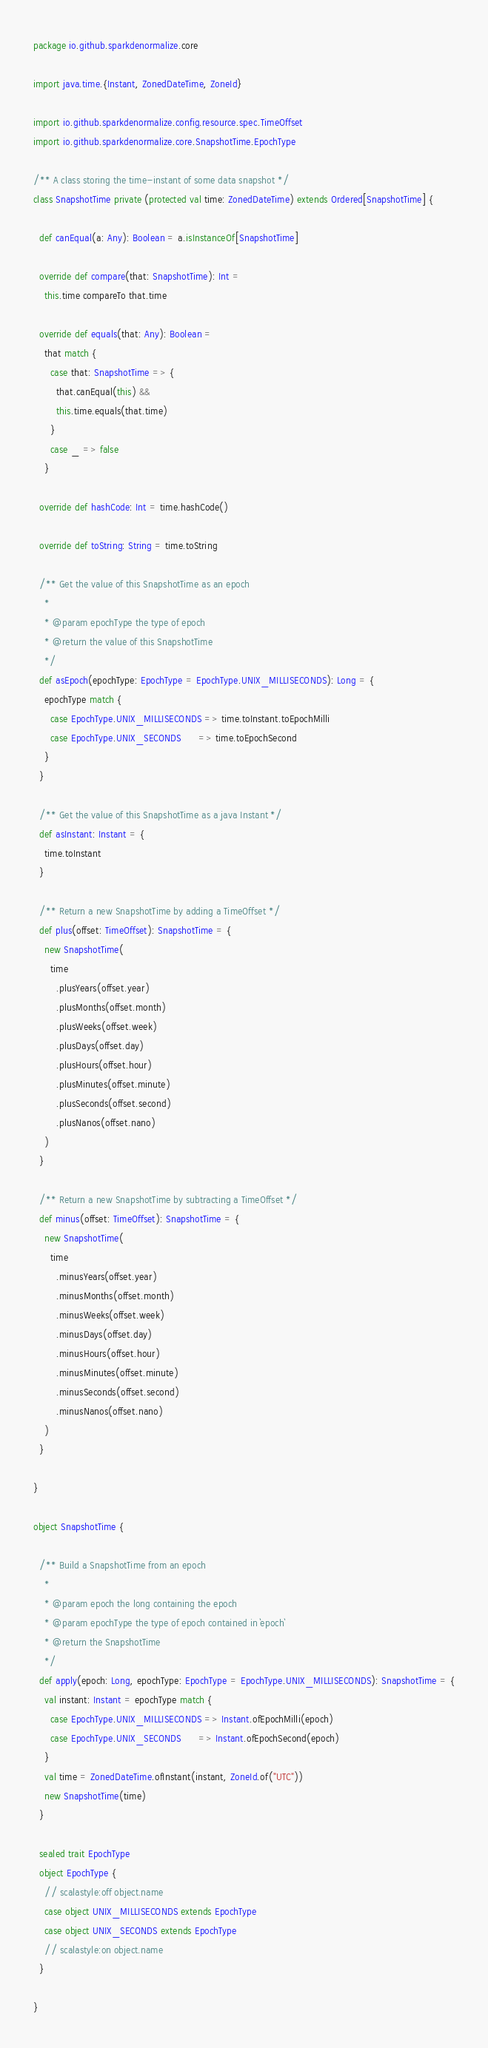Convert code to text. <code><loc_0><loc_0><loc_500><loc_500><_Scala_>package io.github.sparkdenormalize.core

import java.time.{Instant, ZonedDateTime, ZoneId}

import io.github.sparkdenormalize.config.resource.spec.TimeOffset
import io.github.sparkdenormalize.core.SnapshotTime.EpochType

/** A class storing the time-instant of some data snapshot */
class SnapshotTime private (protected val time: ZonedDateTime) extends Ordered[SnapshotTime] {

  def canEqual(a: Any): Boolean = a.isInstanceOf[SnapshotTime]

  override def compare(that: SnapshotTime): Int =
    this.time compareTo that.time

  override def equals(that: Any): Boolean =
    that match {
      case that: SnapshotTime => {
        that.canEqual(this) &&
        this.time.equals(that.time)
      }
      case _ => false
    }

  override def hashCode: Int = time.hashCode()

  override def toString: String = time.toString

  /** Get the value of this SnapshotTime as an epoch
    *
    * @param epochType the type of epoch
    * @return the value of this SnapshotTime
    */
  def asEpoch(epochType: EpochType = EpochType.UNIX_MILLISECONDS): Long = {
    epochType match {
      case EpochType.UNIX_MILLISECONDS => time.toInstant.toEpochMilli
      case EpochType.UNIX_SECONDS      => time.toEpochSecond
    }
  }

  /** Get the value of this SnapshotTime as a java Instant */
  def asInstant: Instant = {
    time.toInstant
  }

  /** Return a new SnapshotTime by adding a TimeOffset */
  def plus(offset: TimeOffset): SnapshotTime = {
    new SnapshotTime(
      time
        .plusYears(offset.year)
        .plusMonths(offset.month)
        .plusWeeks(offset.week)
        .plusDays(offset.day)
        .plusHours(offset.hour)
        .plusMinutes(offset.minute)
        .plusSeconds(offset.second)
        .plusNanos(offset.nano)
    )
  }

  /** Return a new SnapshotTime by subtracting a TimeOffset */
  def minus(offset: TimeOffset): SnapshotTime = {
    new SnapshotTime(
      time
        .minusYears(offset.year)
        .minusMonths(offset.month)
        .minusWeeks(offset.week)
        .minusDays(offset.day)
        .minusHours(offset.hour)
        .minusMinutes(offset.minute)
        .minusSeconds(offset.second)
        .minusNanos(offset.nano)
    )
  }

}

object SnapshotTime {

  /** Build a SnapshotTime from an epoch
    *
    * @param epoch the long containing the epoch
    * @param epochType the type of epoch contained in `epoch`
    * @return the SnapshotTime
    */
  def apply(epoch: Long, epochType: EpochType = EpochType.UNIX_MILLISECONDS): SnapshotTime = {
    val instant: Instant = epochType match {
      case EpochType.UNIX_MILLISECONDS => Instant.ofEpochMilli(epoch)
      case EpochType.UNIX_SECONDS      => Instant.ofEpochSecond(epoch)
    }
    val time = ZonedDateTime.ofInstant(instant, ZoneId.of("UTC"))
    new SnapshotTime(time)
  }

  sealed trait EpochType
  object EpochType {
    // scalastyle:off object.name
    case object UNIX_MILLISECONDS extends EpochType
    case object UNIX_SECONDS extends EpochType
    // scalastyle:on object.name
  }

}
</code> 